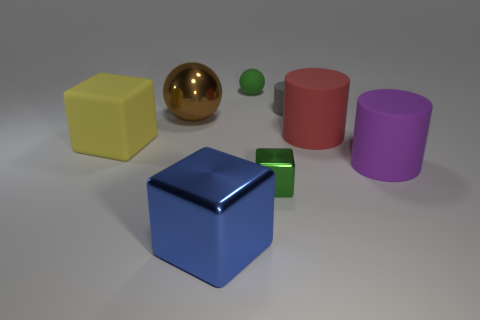Subtract all big cubes. How many cubes are left? 1 Add 1 small blue rubber spheres. How many objects exist? 9 Subtract all cylinders. How many objects are left? 5 Subtract all blue cylinders. Subtract all yellow blocks. How many cylinders are left? 3 Add 4 green rubber things. How many green rubber things are left? 5 Add 4 big matte blocks. How many big matte blocks exist? 5 Subtract 0 brown blocks. How many objects are left? 8 Subtract all blue spheres. Subtract all small gray things. How many objects are left? 7 